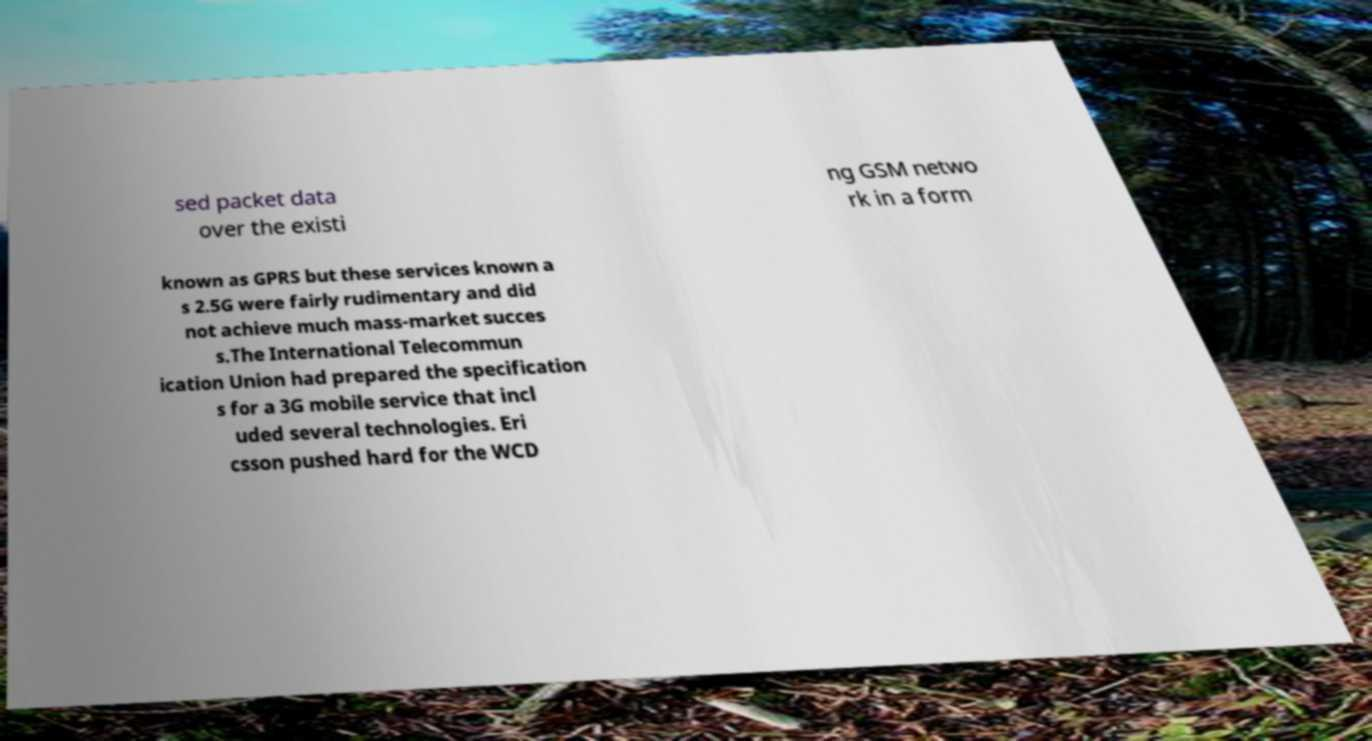I need the written content from this picture converted into text. Can you do that? sed packet data over the existi ng GSM netwo rk in a form known as GPRS but these services known a s 2.5G were fairly rudimentary and did not achieve much mass-market succes s.The International Telecommun ication Union had prepared the specification s for a 3G mobile service that incl uded several technologies. Eri csson pushed hard for the WCD 